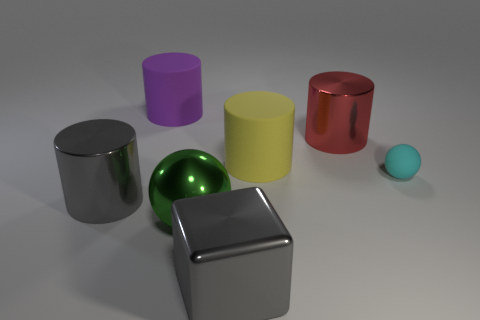Is the number of purple matte cylinders in front of the gray shiny cube the same as the number of purple rubber objects?
Make the answer very short. No. There is a big rubber thing that is behind the yellow thing; is there a yellow rubber object in front of it?
Offer a terse response. Yes. Is there anything else that has the same color as the metal block?
Make the answer very short. Yes. Is the material of the sphere that is in front of the big gray metallic cylinder the same as the big red cylinder?
Offer a very short reply. Yes. Are there the same number of gray blocks that are behind the big sphere and matte balls that are to the right of the rubber ball?
Make the answer very short. Yes. What size is the metallic cylinder that is to the right of the gray metallic object in front of the gray cylinder?
Make the answer very short. Large. There is a large cylinder that is both to the right of the green object and to the left of the big red cylinder; what is its material?
Keep it short and to the point. Rubber. How many other objects are there of the same size as the green thing?
Offer a very short reply. 5. What color is the metal ball?
Your answer should be compact. Green. There is a big metallic cylinder that is to the left of the big yellow matte cylinder; is it the same color as the metal object in front of the metal sphere?
Make the answer very short. Yes. 